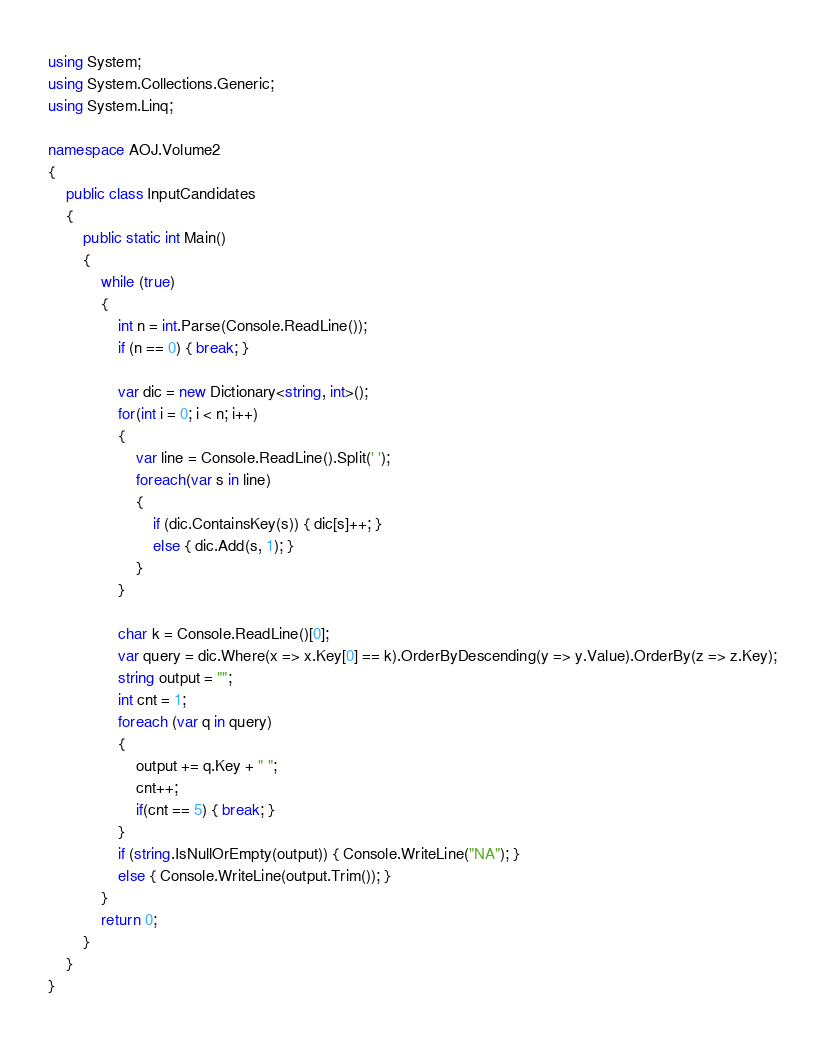<code> <loc_0><loc_0><loc_500><loc_500><_C#_>using System;
using System.Collections.Generic;
using System.Linq;

namespace AOJ.Volume2
{
    public class InputCandidates
    {
        public static int Main()
        {
            while (true)
            {
                int n = int.Parse(Console.ReadLine());
                if (n == 0) { break; }

                var dic = new Dictionary<string, int>();
                for(int i = 0; i < n; i++)
                {
                    var line = Console.ReadLine().Split(' ');
                    foreach(var s in line)
                    {
                        if (dic.ContainsKey(s)) { dic[s]++; }
                        else { dic.Add(s, 1); }
                    }
                }

                char k = Console.ReadLine()[0];
                var query = dic.Where(x => x.Key[0] == k).OrderByDescending(y => y.Value).OrderBy(z => z.Key);
                string output = "";
                int cnt = 1;
                foreach (var q in query)
                {
                    output += q.Key + " ";
                    cnt++;
                    if(cnt == 5) { break; }
                }
                if (string.IsNullOrEmpty(output)) { Console.WriteLine("NA"); }
                else { Console.WriteLine(output.Trim()); }
            }
            return 0;
        }
    }
}</code> 